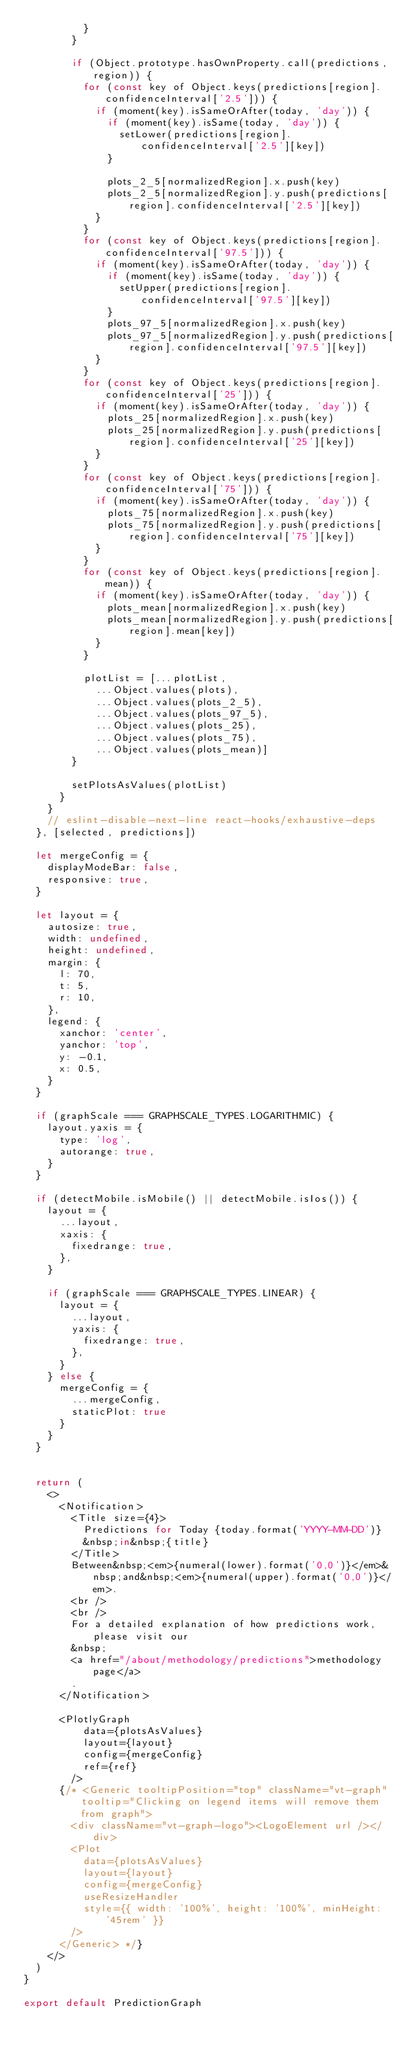Convert code to text. <code><loc_0><loc_0><loc_500><loc_500><_JavaScript_>          }
        }

        if (Object.prototype.hasOwnProperty.call(predictions, region)) {
          for (const key of Object.keys(predictions[region].confidenceInterval['2.5'])) {
            if (moment(key).isSameOrAfter(today, 'day')) {
              if (moment(key).isSame(today, 'day')) {
                setLower(predictions[region].confidenceInterval['2.5'][key])
              }

              plots_2_5[normalizedRegion].x.push(key)
              plots_2_5[normalizedRegion].y.push(predictions[region].confidenceInterval['2.5'][key])
            }
          }
          for (const key of Object.keys(predictions[region].confidenceInterval['97.5'])) {
            if (moment(key).isSameOrAfter(today, 'day')) {
              if (moment(key).isSame(today, 'day')) {
                setUpper(predictions[region].confidenceInterval['97.5'][key])
              }
              plots_97_5[normalizedRegion].x.push(key)
              plots_97_5[normalizedRegion].y.push(predictions[region].confidenceInterval['97.5'][key])
            }
          }
          for (const key of Object.keys(predictions[region].confidenceInterval['25'])) {
            if (moment(key).isSameOrAfter(today, 'day')) {
              plots_25[normalizedRegion].x.push(key)
              plots_25[normalizedRegion].y.push(predictions[region].confidenceInterval['25'][key])
            }
          }
          for (const key of Object.keys(predictions[region].confidenceInterval['75'])) {
            if (moment(key).isSameOrAfter(today, 'day')) {
              plots_75[normalizedRegion].x.push(key)
              plots_75[normalizedRegion].y.push(predictions[region].confidenceInterval['75'][key])
            }
          }
          for (const key of Object.keys(predictions[region].mean)) {
            if (moment(key).isSameOrAfter(today, 'day')) {
              plots_mean[normalizedRegion].x.push(key)
              plots_mean[normalizedRegion].y.push(predictions[region].mean[key])
            }
          }

          plotList = [...plotList,
            ...Object.values(plots),
            ...Object.values(plots_2_5),
            ...Object.values(plots_97_5),
            ...Object.values(plots_25),
            ...Object.values(plots_75),
            ...Object.values(plots_mean)]
        }

        setPlotsAsValues(plotList)
      }
    }
    // eslint-disable-next-line react-hooks/exhaustive-deps
  }, [selected, predictions])

  let mergeConfig = {
    displayModeBar: false,
    responsive: true,
  }

  let layout = {
    autosize: true,
    width: undefined,
    height: undefined,
    margin: {
      l: 70,
      t: 5,
      r: 10,
    },
    legend: {
      xanchor: 'center',
      yanchor: 'top',
      y: -0.1,
      x: 0.5,
    }
  }

  if (graphScale === GRAPHSCALE_TYPES.LOGARITHMIC) {
    layout.yaxis = {
      type: 'log',
      autorange: true,
    }
  }

  if (detectMobile.isMobile() || detectMobile.isIos()) {
    layout = {
      ...layout,
      xaxis: {
        fixedrange: true,
      },
    }

    if (graphScale === GRAPHSCALE_TYPES.LINEAR) {
      layout = {
        ...layout,
        yaxis: {
          fixedrange: true,
        },
      }
    } else {
      mergeConfig = {
        ...mergeConfig,
        staticPlot: true
      }
    }
  }


  return (
    <>
      <Notification>
        <Title size={4}>
          Predictions for Today {today.format('YYYY-MM-DD')}
          &nbsp;in&nbsp;{title}
        </Title>
        Between&nbsp;<em>{numeral(lower).format('0,0')}</em>&nbsp;and&nbsp;<em>{numeral(upper).format('0,0')}</em>.
        <br />
        <br />
        For a detailed explanation of how predictions work, please visit our
        &nbsp;
        <a href="/about/methodology/predictions">methodology page</a>
        .
      </Notification>

      <PlotlyGraph 
          data={plotsAsValues}
          layout={layout}
          config={mergeConfig}
          ref={ref} 
        />
      {/* <Generic tooltipPosition="top" className="vt-graph" tooltip="Clicking on legend items will remove them from graph">
        <div className="vt-graph-logo"><LogoElement url /></div>
        <Plot
          data={plotsAsValues}
          layout={layout}
          config={mergeConfig}
          useResizeHandler
          style={{ width: '100%', height: '100%', minHeight: '45rem' }}
        />
      </Generic> */}
    </>
  )
}

export default PredictionGraph
</code> 